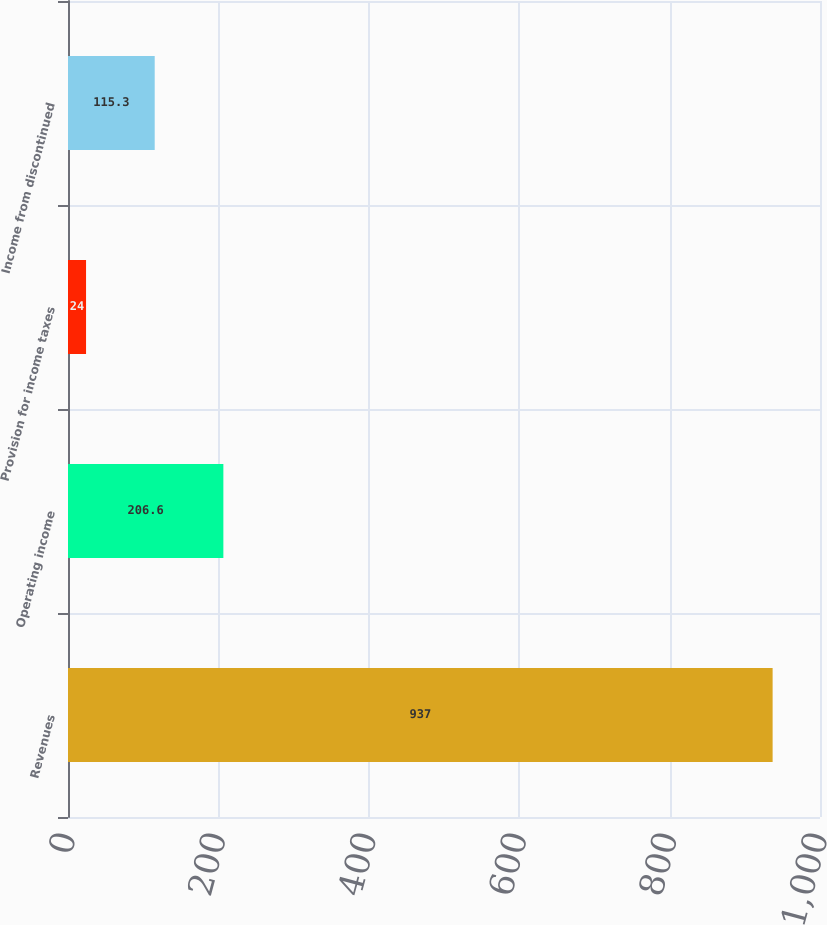Convert chart to OTSL. <chart><loc_0><loc_0><loc_500><loc_500><bar_chart><fcel>Revenues<fcel>Operating income<fcel>Provision for income taxes<fcel>Income from discontinued<nl><fcel>937<fcel>206.6<fcel>24<fcel>115.3<nl></chart> 